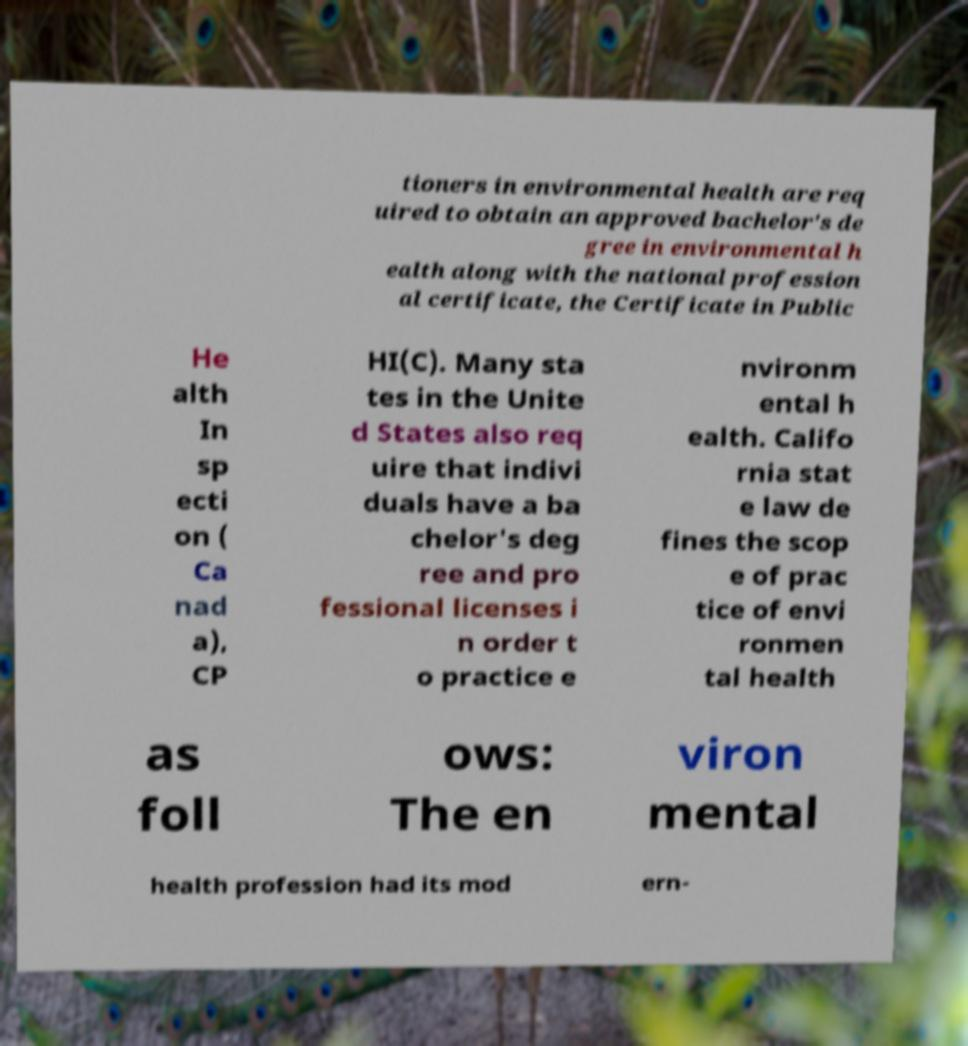Please read and relay the text visible in this image. What does it say? tioners in environmental health are req uired to obtain an approved bachelor's de gree in environmental h ealth along with the national profession al certificate, the Certificate in Public He alth In sp ecti on ( Ca nad a), CP HI(C). Many sta tes in the Unite d States also req uire that indivi duals have a ba chelor's deg ree and pro fessional licenses i n order t o practice e nvironm ental h ealth. Califo rnia stat e law de fines the scop e of prac tice of envi ronmen tal health as foll ows: The en viron mental health profession had its mod ern- 